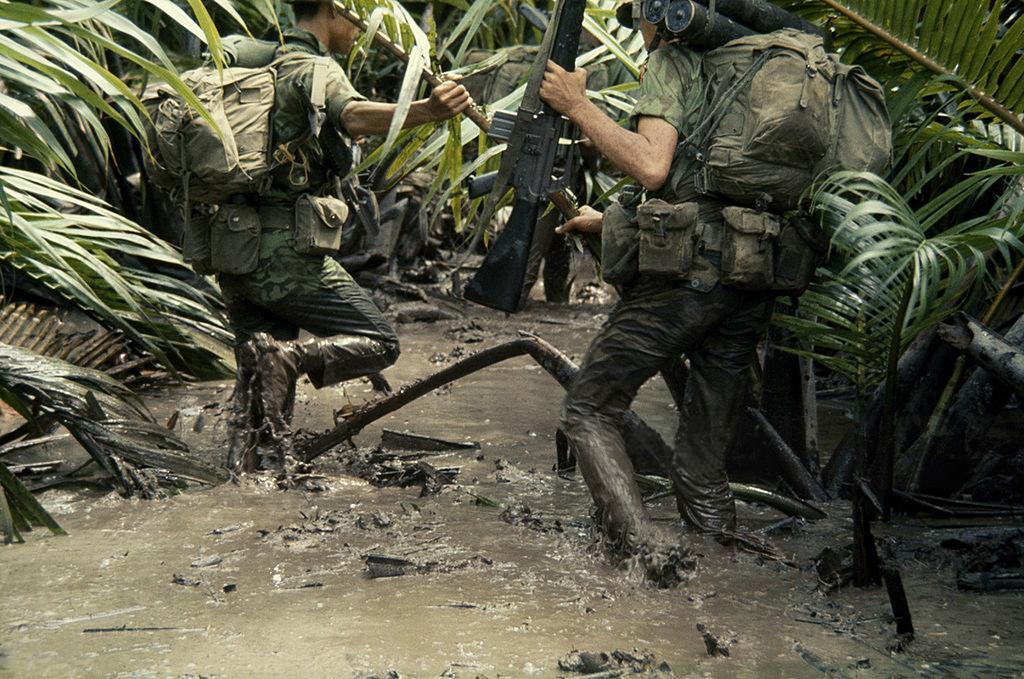How would you summarize this image in a sentence or two? In this image there are two persons standing in the mud water, and in the background there are trees. 